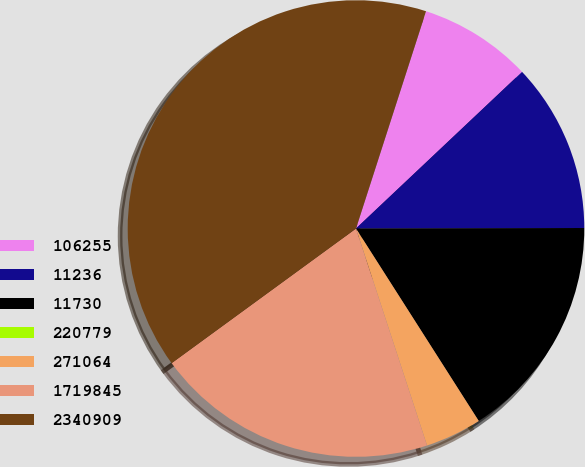Convert chart to OTSL. <chart><loc_0><loc_0><loc_500><loc_500><pie_chart><fcel>106255<fcel>11236<fcel>11730<fcel>220779<fcel>271064<fcel>1719845<fcel>2340909<nl><fcel>8.0%<fcel>12.0%<fcel>16.0%<fcel>0.0%<fcel>4.0%<fcel>20.0%<fcel>40.0%<nl></chart> 